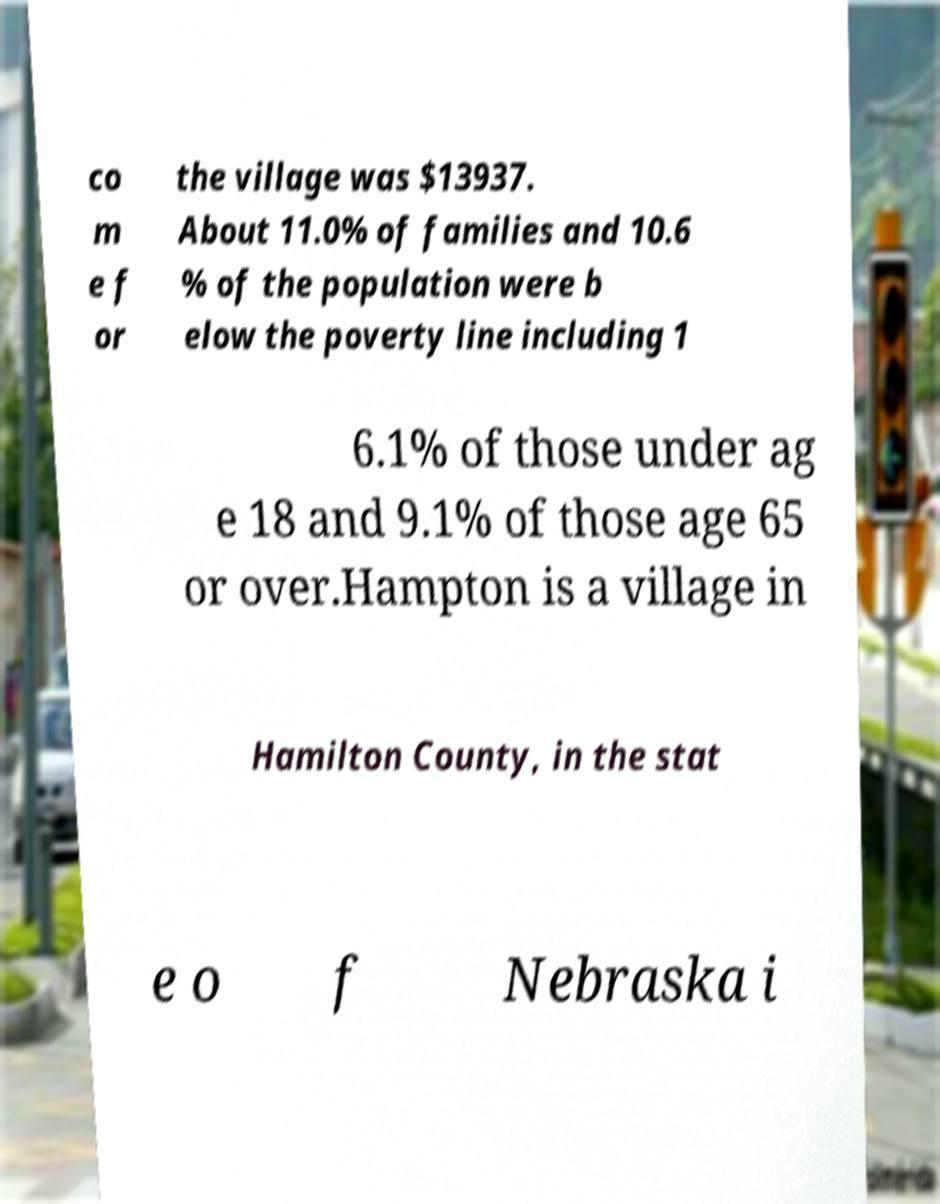I need the written content from this picture converted into text. Can you do that? co m e f or the village was $13937. About 11.0% of families and 10.6 % of the population were b elow the poverty line including 1 6.1% of those under ag e 18 and 9.1% of those age 65 or over.Hampton is a village in Hamilton County, in the stat e o f Nebraska i 